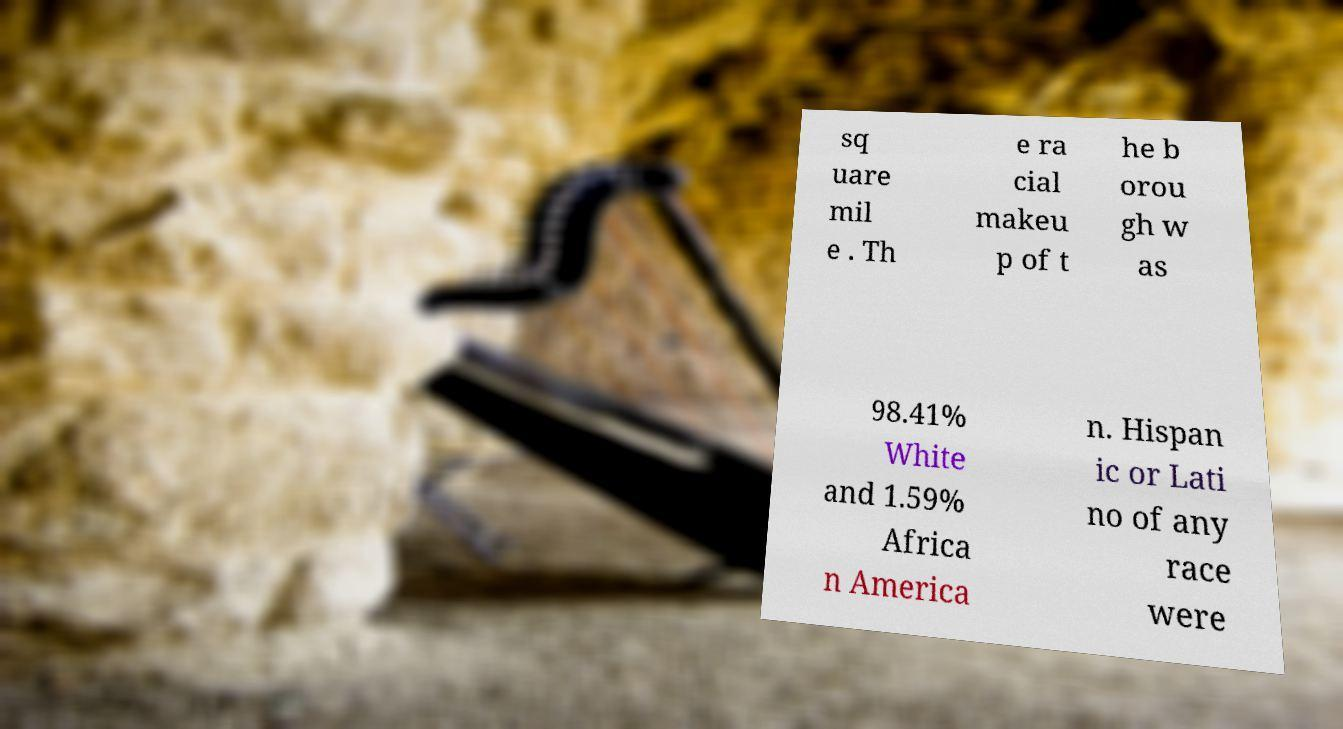For documentation purposes, I need the text within this image transcribed. Could you provide that? sq uare mil e . Th e ra cial makeu p of t he b orou gh w as 98.41% White and 1.59% Africa n America n. Hispan ic or Lati no of any race were 